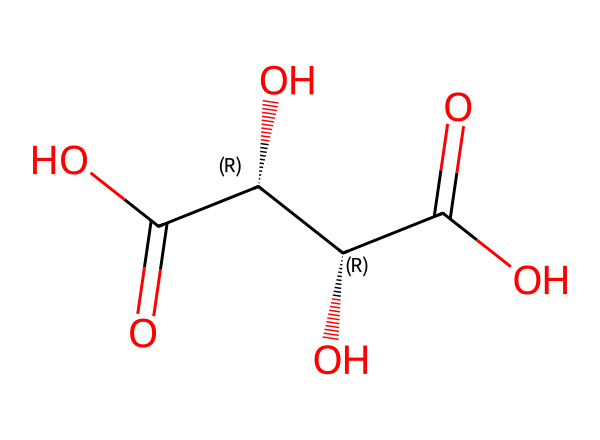What is the molecular formula of tartaric acid? The molecular formula can be determined by counting the number of carbon (C), hydrogen (H), and oxygen (O) atoms in the provided structure. There are 4 carbons, 6 hydrogens, and 5 oxygens, giving a formula of C4H6O6.
Answer: C4H6O6 How many chiral centers are present in tartaric acid? A chiral center is typically identified by looking for carbon atoms that are attached to four different groups. In the structure, there are two carbon atoms with 4 different substituents, indicating that there are two chiral centers.
Answer: 2 What is the stereochemical configuration of the first chiral center? The first chiral center (C@H) has a specific arrangement of its substituents which gives it a specific configuration. After analyzing the substituents (hydroxyl, hydrogen, carboxyl groups), we can determine that it is designated as R (rectus).
Answer: R Which functional groups are present in tartaric acid? By examining the structure, we see the presence of carboxylic acid groups (-COOH) and hydroxyl groups (-OH). The counting shows there are two carboxylic groups and two hydroxyl groups in the structure.
Answer: carboxylic acids and hydroxyl groups How does the presence of chiral centers affect the properties of tartaric acid? Chiral centers lead to the existence of enantiomers, which can have different tastes and olfactory properties. In the context of wine, this can affect flavor and aroma profiles. The presence of the two chiral centers specifically means that tartaric acid can exist in multiple stereoisomeric forms, influencing its roles in wine.
Answer: different isomers affect flavor and aroma What type of acid is tartaric acid classified as? This compound is classified by its functional groups; it contains carboxylic acid groups, confirming its classification as an organic acid.
Answer: organic acid 